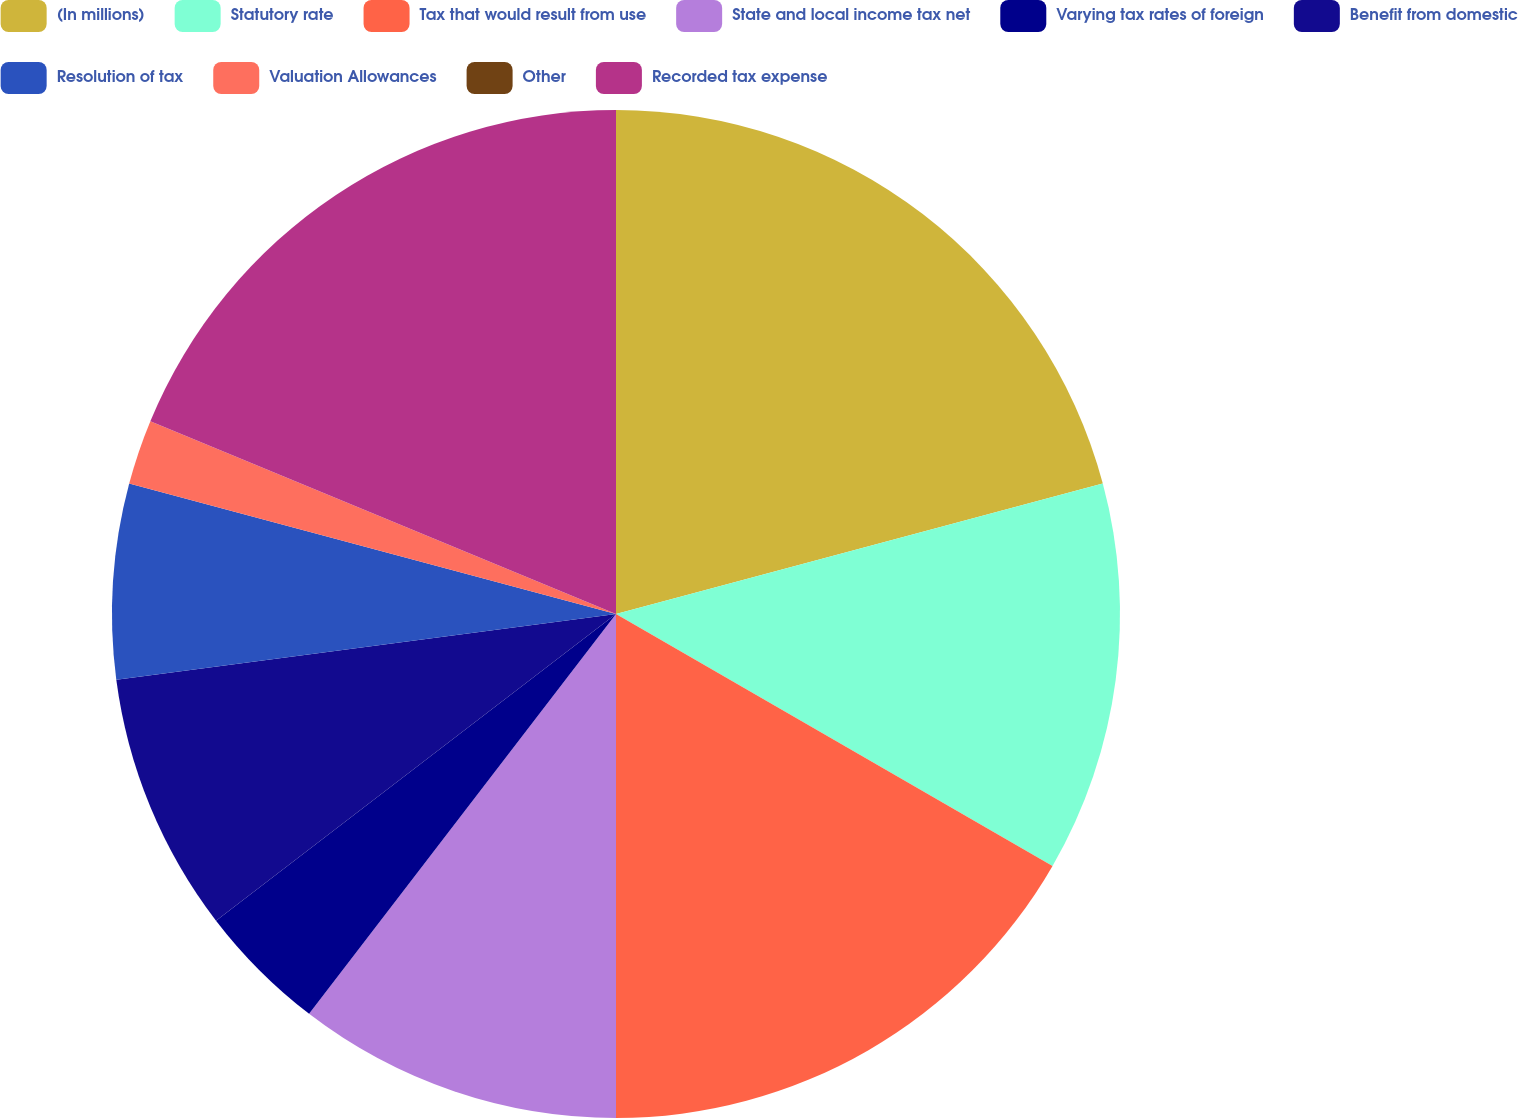Convert chart. <chart><loc_0><loc_0><loc_500><loc_500><pie_chart><fcel>(In millions)<fcel>Statutory rate<fcel>Tax that would result from use<fcel>State and local income tax net<fcel>Varying tax rates of foreign<fcel>Benefit from domestic<fcel>Resolution of tax<fcel>Valuation Allowances<fcel>Other<fcel>Recorded tax expense<nl><fcel>20.83%<fcel>12.5%<fcel>16.67%<fcel>10.42%<fcel>4.17%<fcel>8.33%<fcel>6.25%<fcel>2.08%<fcel>0.0%<fcel>18.75%<nl></chart> 